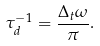<formula> <loc_0><loc_0><loc_500><loc_500>\tau ^ { - 1 } _ { d } = \frac { \Delta _ { t } \omega } { \pi } .</formula> 